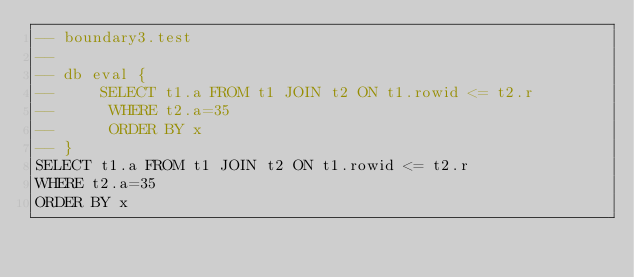<code> <loc_0><loc_0><loc_500><loc_500><_SQL_>-- boundary3.test
-- 
-- db eval {
--     SELECT t1.a FROM t1 JOIN t2 ON t1.rowid <= t2.r
--      WHERE t2.a=35
--      ORDER BY x
-- }
SELECT t1.a FROM t1 JOIN t2 ON t1.rowid <= t2.r
WHERE t2.a=35
ORDER BY x</code> 